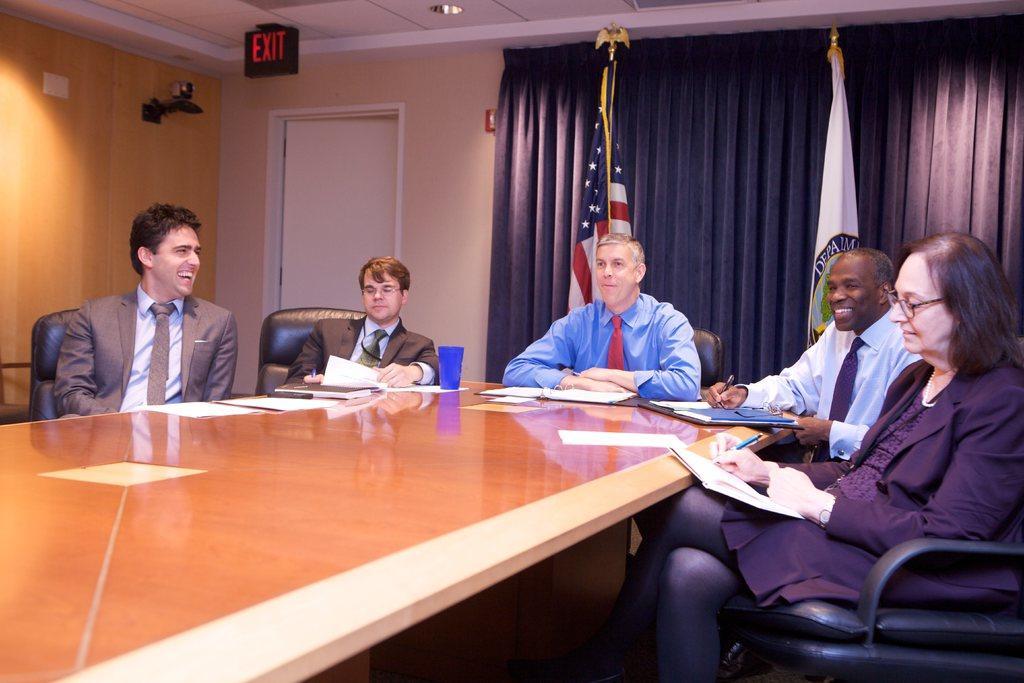How would you summarize this image in a sentence or two? In this images there is a table which is in yellow color and there are some people sitting on the chairs and on the table there is glass of blue color and in the background there is a wall which in white color. 